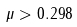<formula> <loc_0><loc_0><loc_500><loc_500>\mu > 0 . 2 9 8</formula> 